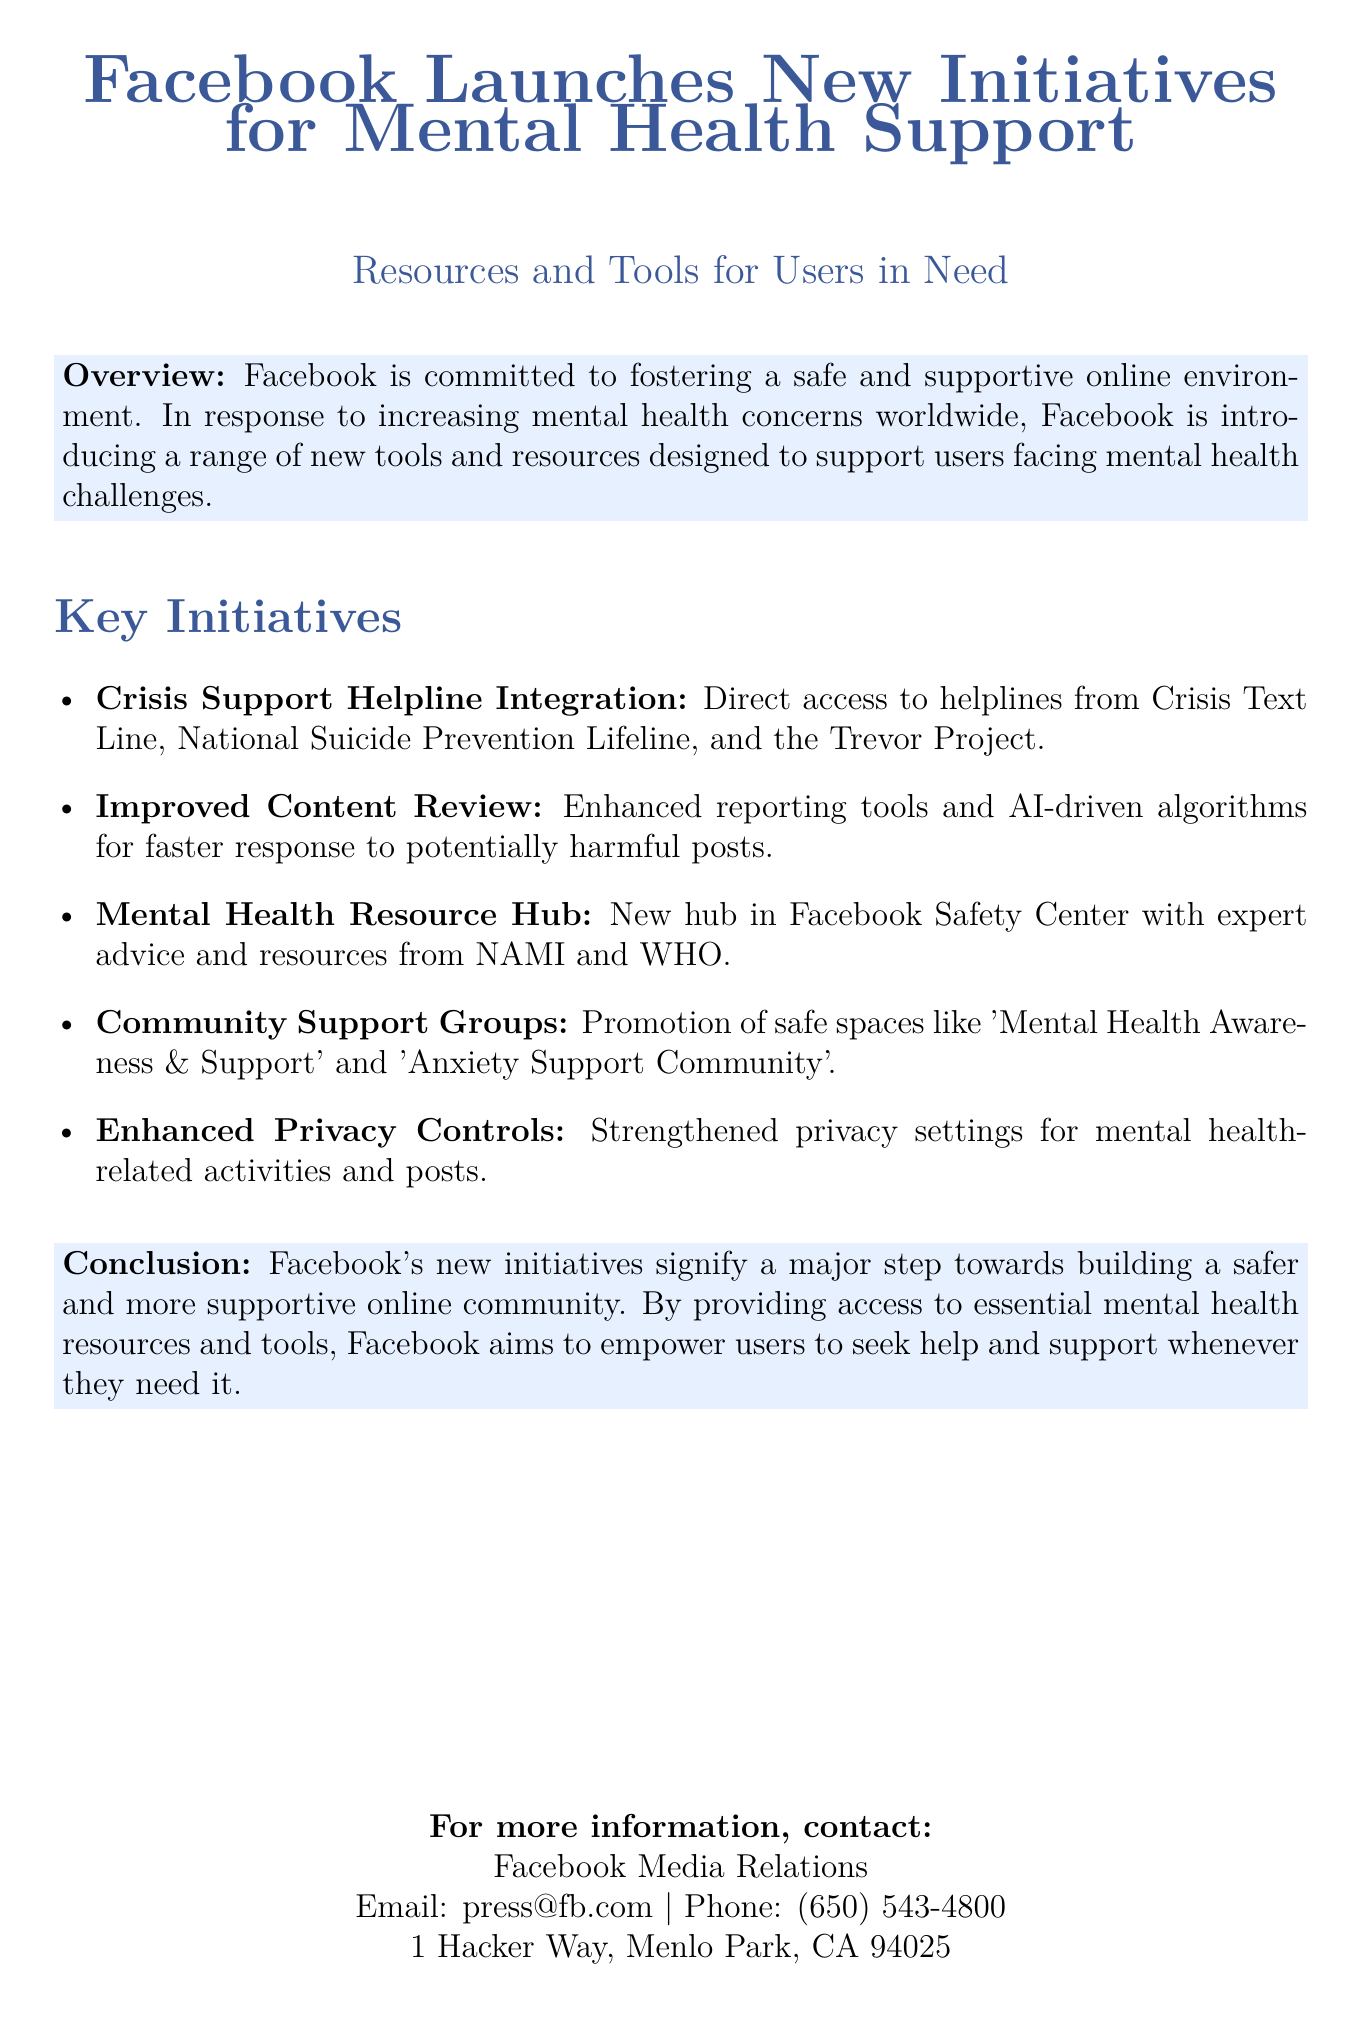What organizations are integrated into the Crisis Support Helpline? The document lists Crisis Text Line, National Suicide Prevention Lifeline, and the Trevor Project as the organizations.
Answer: Crisis Text Line, National Suicide Prevention Lifeline, Trevor Project What is the focus of Facebook’s new initiatives? The document states that Facebook's initiatives focus on fostering a safe and supportive online environment amidst increasing mental health concerns.
Answer: Mental health support How is the content reviewed according to the new initiatives? The document mentions that improved content review involves enhanced reporting tools and AI-driven algorithms for faster response.
Answer: Enhanced reporting tools and AI-driven algorithms Where can users find the Mental Health Resource Hub? The document specifies that the hub is located in Facebook Safety Center.
Answer: Facebook Safety Center How many community support groups are mentioned? The document directly lists two community support groups aimed at mental health support.
Answer: Two What is one feature of the Enhanced Privacy Controls? The document states that the privacy settings for mental health-related activities are strengthened as part of the features.
Answer: Strengthened privacy settings What overall step does Facebook's new initiatives signify? The document describes these initiatives as a major step towards building a safer and more supportive online community.
Answer: Major step What is the contact email for Facebook Media Relations? The contact email for inquiries as provided in the document is specified as press@fb.com.
Answer: press@fb.com 